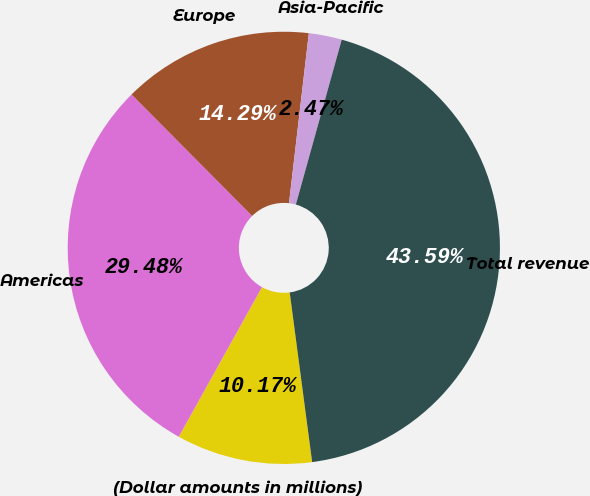Convert chart. <chart><loc_0><loc_0><loc_500><loc_500><pie_chart><fcel>(Dollar amounts in millions)<fcel>Americas<fcel>Europe<fcel>Asia-Pacific<fcel>Total revenue<nl><fcel>10.17%<fcel>29.48%<fcel>14.29%<fcel>2.47%<fcel>43.59%<nl></chart> 